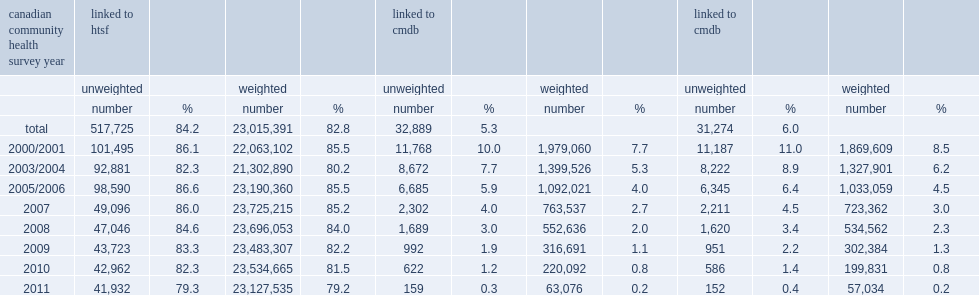What percentage of eligible cchs respondents linked to the htsf? 84.2. List the lowest and the highest rate of eligible cchs respondents linked to the htsf ranged across survey years. 79.3 86.6. Overall, what percentage of eligible cchs respondents linked to the cmdb? 5.3. 